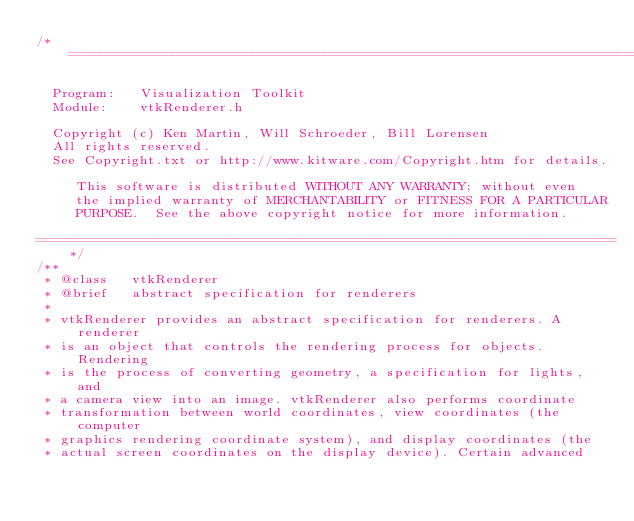Convert code to text. <code><loc_0><loc_0><loc_500><loc_500><_C_>/*=========================================================================

  Program:   Visualization Toolkit
  Module:    vtkRenderer.h

  Copyright (c) Ken Martin, Will Schroeder, Bill Lorensen
  All rights reserved.
  See Copyright.txt or http://www.kitware.com/Copyright.htm for details.

     This software is distributed WITHOUT ANY WARRANTY; without even
     the implied warranty of MERCHANTABILITY or FITNESS FOR A PARTICULAR
     PURPOSE.  See the above copyright notice for more information.

=========================================================================*/
/**
 * @class   vtkRenderer
 * @brief   abstract specification for renderers
 *
 * vtkRenderer provides an abstract specification for renderers. A renderer
 * is an object that controls the rendering process for objects. Rendering
 * is the process of converting geometry, a specification for lights, and
 * a camera view into an image. vtkRenderer also performs coordinate
 * transformation between world coordinates, view coordinates (the computer
 * graphics rendering coordinate system), and display coordinates (the
 * actual screen coordinates on the display device). Certain advanced</code> 